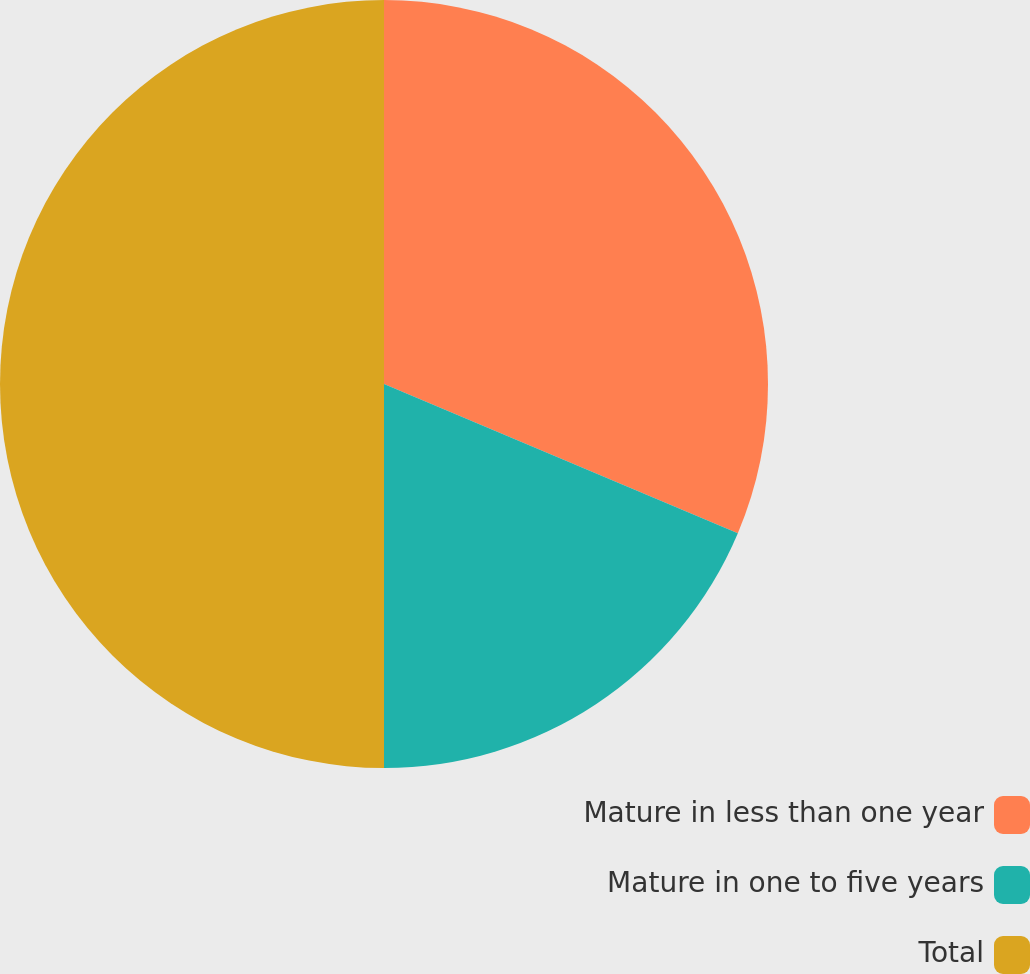Convert chart. <chart><loc_0><loc_0><loc_500><loc_500><pie_chart><fcel>Mature in less than one year<fcel>Mature in one to five years<fcel>Total<nl><fcel>31.35%<fcel>18.65%<fcel>50.0%<nl></chart> 